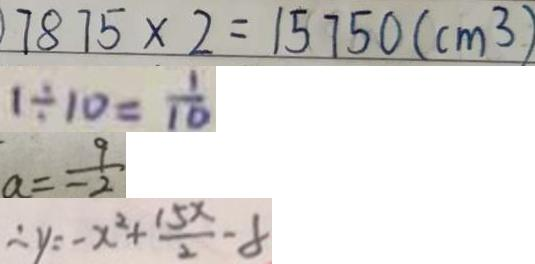<formula> <loc_0><loc_0><loc_500><loc_500>7 8 7 5 \times 2 = 1 5 7 5 0 ( c m ^ { 3 } ) 
 1 \div 1 0 = \frac { 1 } { 1 0 } 
 a = \frac { 9 } { - 2 } 
 \therefore y = - x ^ { 2 } + \frac { 1 5 x } { 2 } - 8</formula> 